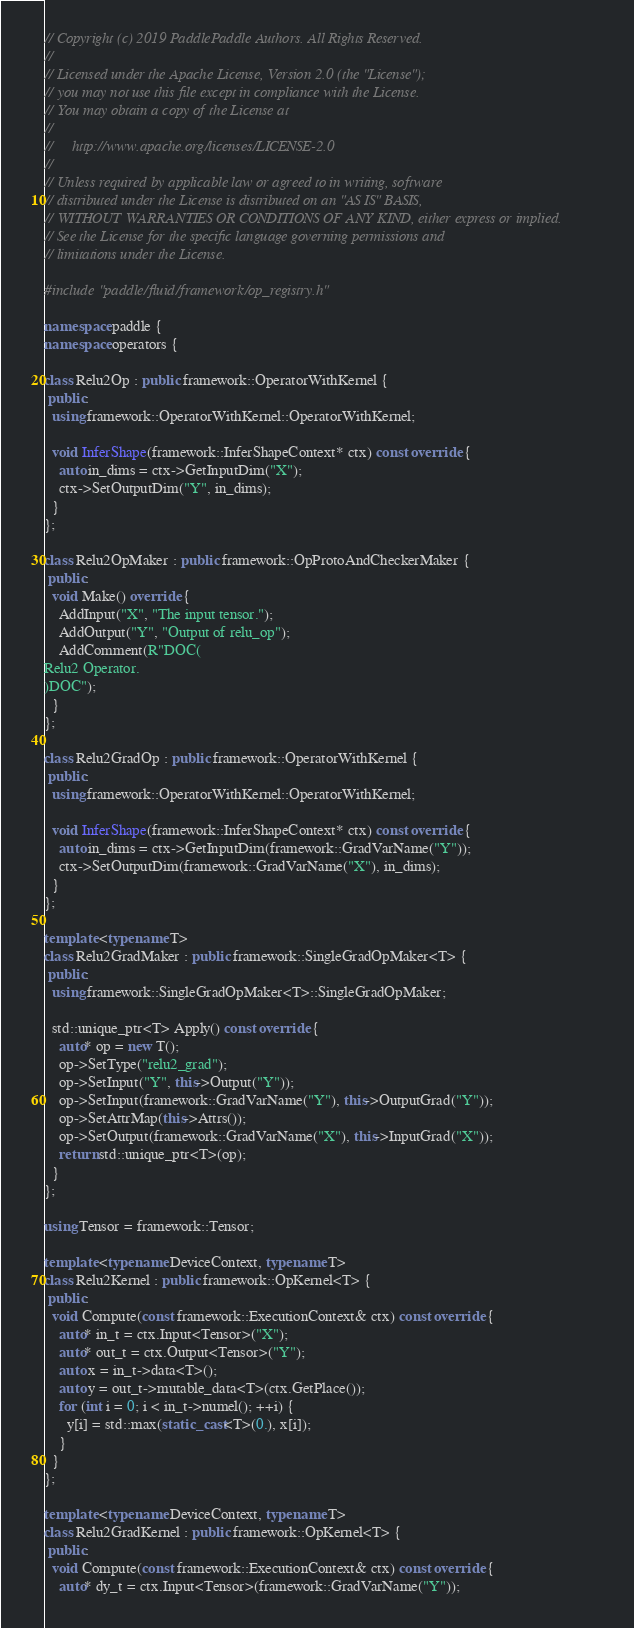<code> <loc_0><loc_0><loc_500><loc_500><_C++_>// Copyright (c) 2019 PaddlePaddle Authors. All Rights Reserved.
//
// Licensed under the Apache License, Version 2.0 (the "License");
// you may not use this file except in compliance with the License.
// You may obtain a copy of the License at
//
//     http://www.apache.org/licenses/LICENSE-2.0
//
// Unless required by applicable law or agreed to in writing, software
// distributed under the License is distributed on an "AS IS" BASIS,
// WITHOUT WARRANTIES OR CONDITIONS OF ANY KIND, either express or implied.
// See the License for the specific language governing permissions and
// limitations under the License.

#include "paddle/fluid/framework/op_registry.h"

namespace paddle {
namespace operators {

class Relu2Op : public framework::OperatorWithKernel {
 public:
  using framework::OperatorWithKernel::OperatorWithKernel;

  void InferShape(framework::InferShapeContext* ctx) const override {
    auto in_dims = ctx->GetInputDim("X");
    ctx->SetOutputDim("Y", in_dims);
  }
};

class Relu2OpMaker : public framework::OpProtoAndCheckerMaker {
 public:
  void Make() override {
    AddInput("X", "The input tensor.");
    AddOutput("Y", "Output of relu_op");
    AddComment(R"DOC(
Relu2 Operator.
)DOC");
  }
};

class Relu2GradOp : public framework::OperatorWithKernel {
 public:
  using framework::OperatorWithKernel::OperatorWithKernel;

  void InferShape(framework::InferShapeContext* ctx) const override {
    auto in_dims = ctx->GetInputDim(framework::GradVarName("Y"));
    ctx->SetOutputDim(framework::GradVarName("X"), in_dims);
  }
};

template <typename T>
class Relu2GradMaker : public framework::SingleGradOpMaker<T> {
 public:
  using framework::SingleGradOpMaker<T>::SingleGradOpMaker;

  std::unique_ptr<T> Apply() const override {
    auto* op = new T();
    op->SetType("relu2_grad");
    op->SetInput("Y", this->Output("Y"));
    op->SetInput(framework::GradVarName("Y"), this->OutputGrad("Y"));
    op->SetAttrMap(this->Attrs());
    op->SetOutput(framework::GradVarName("X"), this->InputGrad("X"));
    return std::unique_ptr<T>(op);
  }
};

using Tensor = framework::Tensor;

template <typename DeviceContext, typename T>
class Relu2Kernel : public framework::OpKernel<T> {
 public:
  void Compute(const framework::ExecutionContext& ctx) const override {
    auto* in_t = ctx.Input<Tensor>("X");
    auto* out_t = ctx.Output<Tensor>("Y");
    auto x = in_t->data<T>();
    auto y = out_t->mutable_data<T>(ctx.GetPlace());
    for (int i = 0; i < in_t->numel(); ++i) {
      y[i] = std::max(static_cast<T>(0.), x[i]);
    }
  }
};

template <typename DeviceContext, typename T>
class Relu2GradKernel : public framework::OpKernel<T> {
 public:
  void Compute(const framework::ExecutionContext& ctx) const override {
    auto* dy_t = ctx.Input<Tensor>(framework::GradVarName("Y"));</code> 